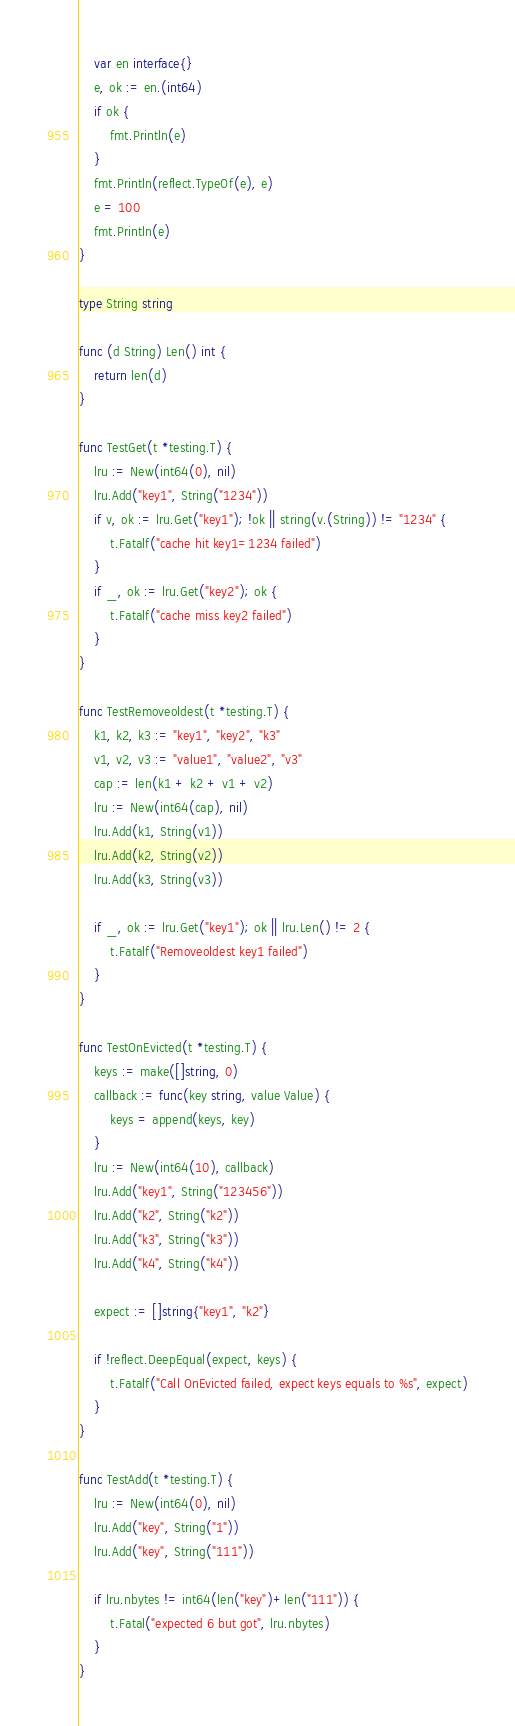Convert code to text. <code><loc_0><loc_0><loc_500><loc_500><_Go_>	var en interface{}
	e, ok := en.(int64)
	if ok {
		fmt.Println(e)
	}
	fmt.Println(reflect.TypeOf(e), e)
	e = 100
	fmt.Println(e)
}

type String string

func (d String) Len() int {
	return len(d)
}

func TestGet(t *testing.T) {
	lru := New(int64(0), nil)
	lru.Add("key1", String("1234"))
	if v, ok := lru.Get("key1"); !ok || string(v.(String)) != "1234" {
		t.Fatalf("cache hit key1=1234 failed")
	}
	if _, ok := lru.Get("key2"); ok {
		t.Fatalf("cache miss key2 failed")
	}
}

func TestRemoveoldest(t *testing.T) {
	k1, k2, k3 := "key1", "key2", "k3"
	v1, v2, v3 := "value1", "value2", "v3"
	cap := len(k1 + k2 + v1 + v2)
	lru := New(int64(cap), nil)
	lru.Add(k1, String(v1))
	lru.Add(k2, String(v2))
	lru.Add(k3, String(v3))

	if _, ok := lru.Get("key1"); ok || lru.Len() != 2 {
		t.Fatalf("Removeoldest key1 failed")
	}
}

func TestOnEvicted(t *testing.T) {
	keys := make([]string, 0)
	callback := func(key string, value Value) {
		keys = append(keys, key)
	}
	lru := New(int64(10), callback)
	lru.Add("key1", String("123456"))
	lru.Add("k2", String("k2"))
	lru.Add("k3", String("k3"))
	lru.Add("k4", String("k4"))

	expect := []string{"key1", "k2"}

	if !reflect.DeepEqual(expect, keys) {
		t.Fatalf("Call OnEvicted failed, expect keys equals to %s", expect)
	}
}

func TestAdd(t *testing.T) {
	lru := New(int64(0), nil)
	lru.Add("key", String("1"))
	lru.Add("key", String("111"))

	if lru.nbytes != int64(len("key")+len("111")) {
		t.Fatal("expected 6 but got", lru.nbytes)
	}
}
</code> 